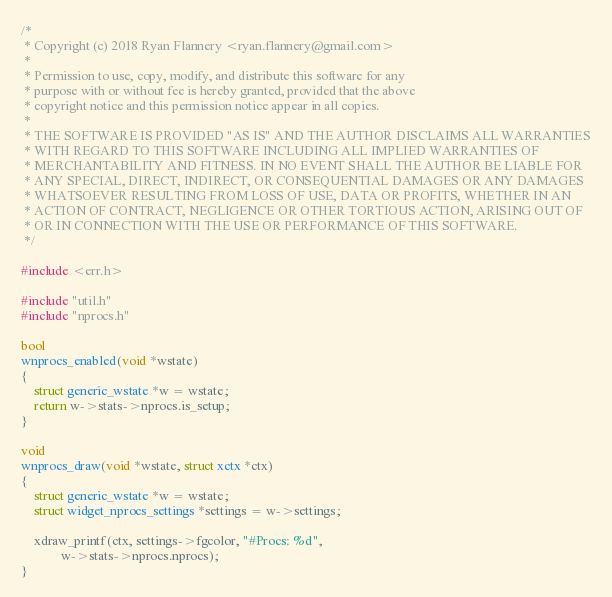Convert code to text. <code><loc_0><loc_0><loc_500><loc_500><_C_>/*
 * Copyright (c) 2018 Ryan Flannery <ryan.flannery@gmail.com>
 *
 * Permission to use, copy, modify, and distribute this software for any
 * purpose with or without fee is hereby granted, provided that the above
 * copyright notice and this permission notice appear in all copies.
 *
 * THE SOFTWARE IS PROVIDED "AS IS" AND THE AUTHOR DISCLAIMS ALL WARRANTIES
 * WITH REGARD TO THIS SOFTWARE INCLUDING ALL IMPLIED WARRANTIES OF
 * MERCHANTABILITY AND FITNESS. IN NO EVENT SHALL THE AUTHOR BE LIABLE FOR
 * ANY SPECIAL, DIRECT, INDIRECT, OR CONSEQUENTIAL DAMAGES OR ANY DAMAGES
 * WHATSOEVER RESULTING FROM LOSS OF USE, DATA OR PROFITS, WHETHER IN AN
 * ACTION OF CONTRACT, NEGLIGENCE OR OTHER TORTIOUS ACTION, ARISING OUT OF
 * OR IN CONNECTION WITH THE USE OR PERFORMANCE OF THIS SOFTWARE.
 */

#include <err.h>

#include "util.h"
#include "nprocs.h"

bool
wnprocs_enabled(void *wstate)
{
	struct generic_wstate *w = wstate;
	return w->stats->nprocs.is_setup;
}

void
wnprocs_draw(void *wstate, struct xctx *ctx)
{
	struct generic_wstate *w = wstate;
	struct widget_nprocs_settings *settings = w->settings;

	xdraw_printf(ctx, settings->fgcolor, "#Procs: %d",
			w->stats->nprocs.nprocs);
}
</code> 